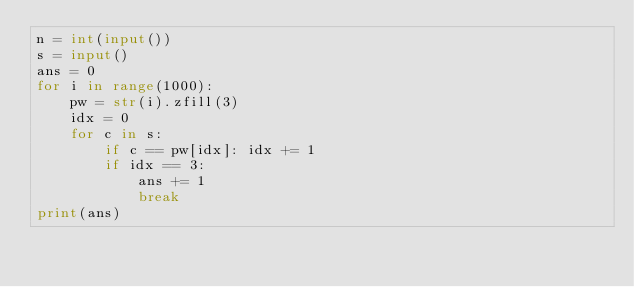Convert code to text. <code><loc_0><loc_0><loc_500><loc_500><_Python_>n = int(input())
s = input()
ans = 0
for i in range(1000):
    pw = str(i).zfill(3)
    idx = 0
    for c in s:
        if c == pw[idx]: idx += 1
        if idx == 3:
            ans += 1
            break
print(ans)</code> 